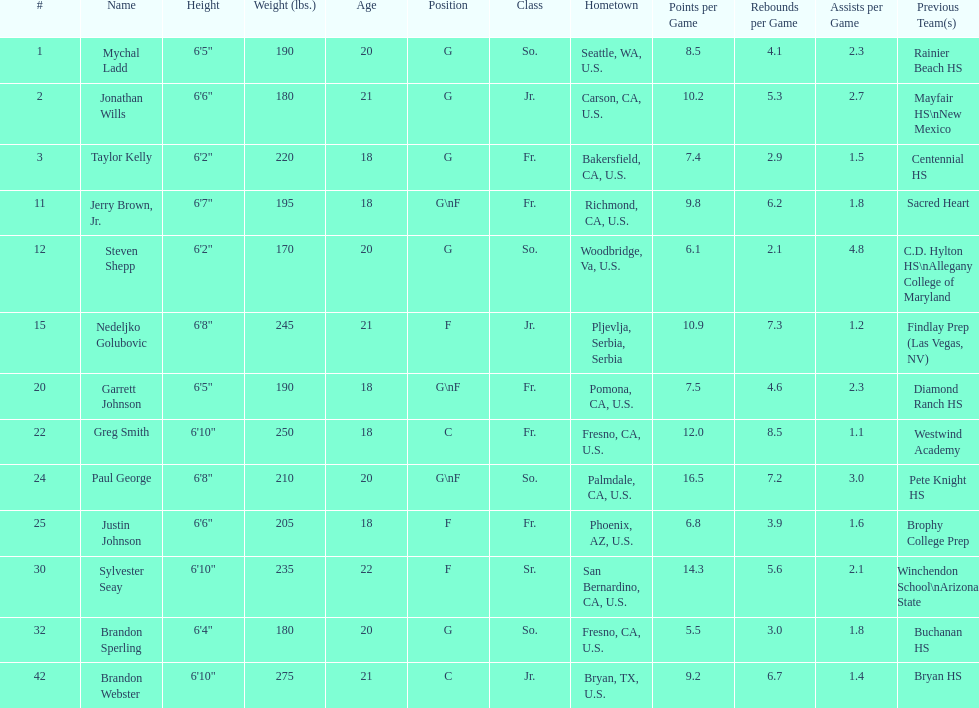Taylor kelly is shorter than 6' 3", which other player is also shorter than 6' 3"? Steven Shepp. Can you give me this table as a dict? {'header': ['#', 'Name', 'Height', 'Weight (lbs.)', 'Age', 'Position', 'Class', 'Hometown', 'Points per Game', 'Rebounds per Game', 'Assists per Game', 'Previous Team(s)'], 'rows': [['1', 'Mychal Ladd', '6\'5"', '190', '20', 'G', 'So.', 'Seattle, WA, U.S.', '8.5', '4.1', '2.3', 'Rainier Beach HS'], ['2', 'Jonathan Wills', '6\'6"', '180', '21', 'G', 'Jr.', 'Carson, CA, U.S.', '10.2', '5.3', '2.7', 'Mayfair HS\\nNew Mexico'], ['3', 'Taylor Kelly', '6\'2"', '220', '18', 'G', 'Fr.', 'Bakersfield, CA, U.S.', '7.4', '2.9', '1.5', 'Centennial HS'], ['11', 'Jerry Brown, Jr.', '6\'7"', '195', '18', 'G\\nF', 'Fr.', 'Richmond, CA, U.S.', '9.8', '6.2', '1.8', 'Sacred Heart'], ['12', 'Steven Shepp', '6\'2"', '170', '20', 'G', 'So.', 'Woodbridge, Va, U.S.', '6.1', '2.1', '4.8', 'C.D. Hylton HS\\nAllegany College of Maryland'], ['15', 'Nedeljko Golubovic', '6\'8"', '245', '21', 'F', 'Jr.', 'Pljevlja, Serbia, Serbia', '10.9', '7.3', '1.2', 'Findlay Prep (Las Vegas, NV)'], ['20', 'Garrett Johnson', '6\'5"', '190', '18', 'G\\nF', 'Fr.', 'Pomona, CA, U.S.', '7.5', '4.6', '2.3', 'Diamond Ranch HS'], ['22', 'Greg Smith', '6\'10"', '250', '18', 'C', 'Fr.', 'Fresno, CA, U.S.', '12.0', '8.5', '1.1', 'Westwind Academy'], ['24', 'Paul George', '6\'8"', '210', '20', 'G\\nF', 'So.', 'Palmdale, CA, U.S.', '16.5', '7.2', '3.0', 'Pete Knight HS'], ['25', 'Justin Johnson', '6\'6"', '205', '18', 'F', 'Fr.', 'Phoenix, AZ, U.S.', '6.8', '3.9', '1.6', 'Brophy College Prep'], ['30', 'Sylvester Seay', '6\'10"', '235', '22', 'F', 'Sr.', 'San Bernardino, CA, U.S.', '14.3', '5.6', '2.1', 'Winchendon School\\nArizona State'], ['32', 'Brandon Sperling', '6\'4"', '180', '20', 'G', 'So.', 'Fresno, CA, U.S.', '5.5', '3.0', '1.8', 'Buchanan HS'], ['42', 'Brandon Webster', '6\'10"', '275', '21', 'C', 'Jr.', 'Bryan, TX, U.S.', '9.2', '6.7', '1.4', 'Bryan HS']]} 